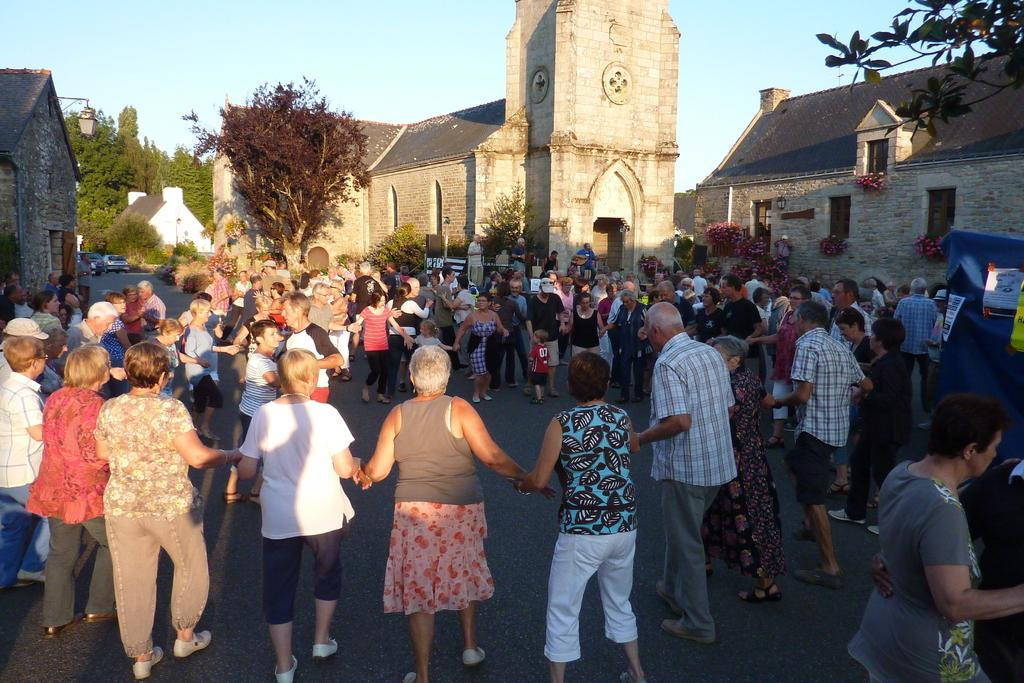How many people are in the image? There is a group of persons standing in the image. What can be seen in the background of the image? There are buildings and trees in the background of the image. What is on the right side of the image? There is a blue color object with some posters on the right side of the image. Can you tell me how many cows are visible in the image? There are no cows present in the image. What type of fruit is being used to support the posters on the right side of the image? There is no fruit present in the image, and the posters are not being supported by any fruit. 